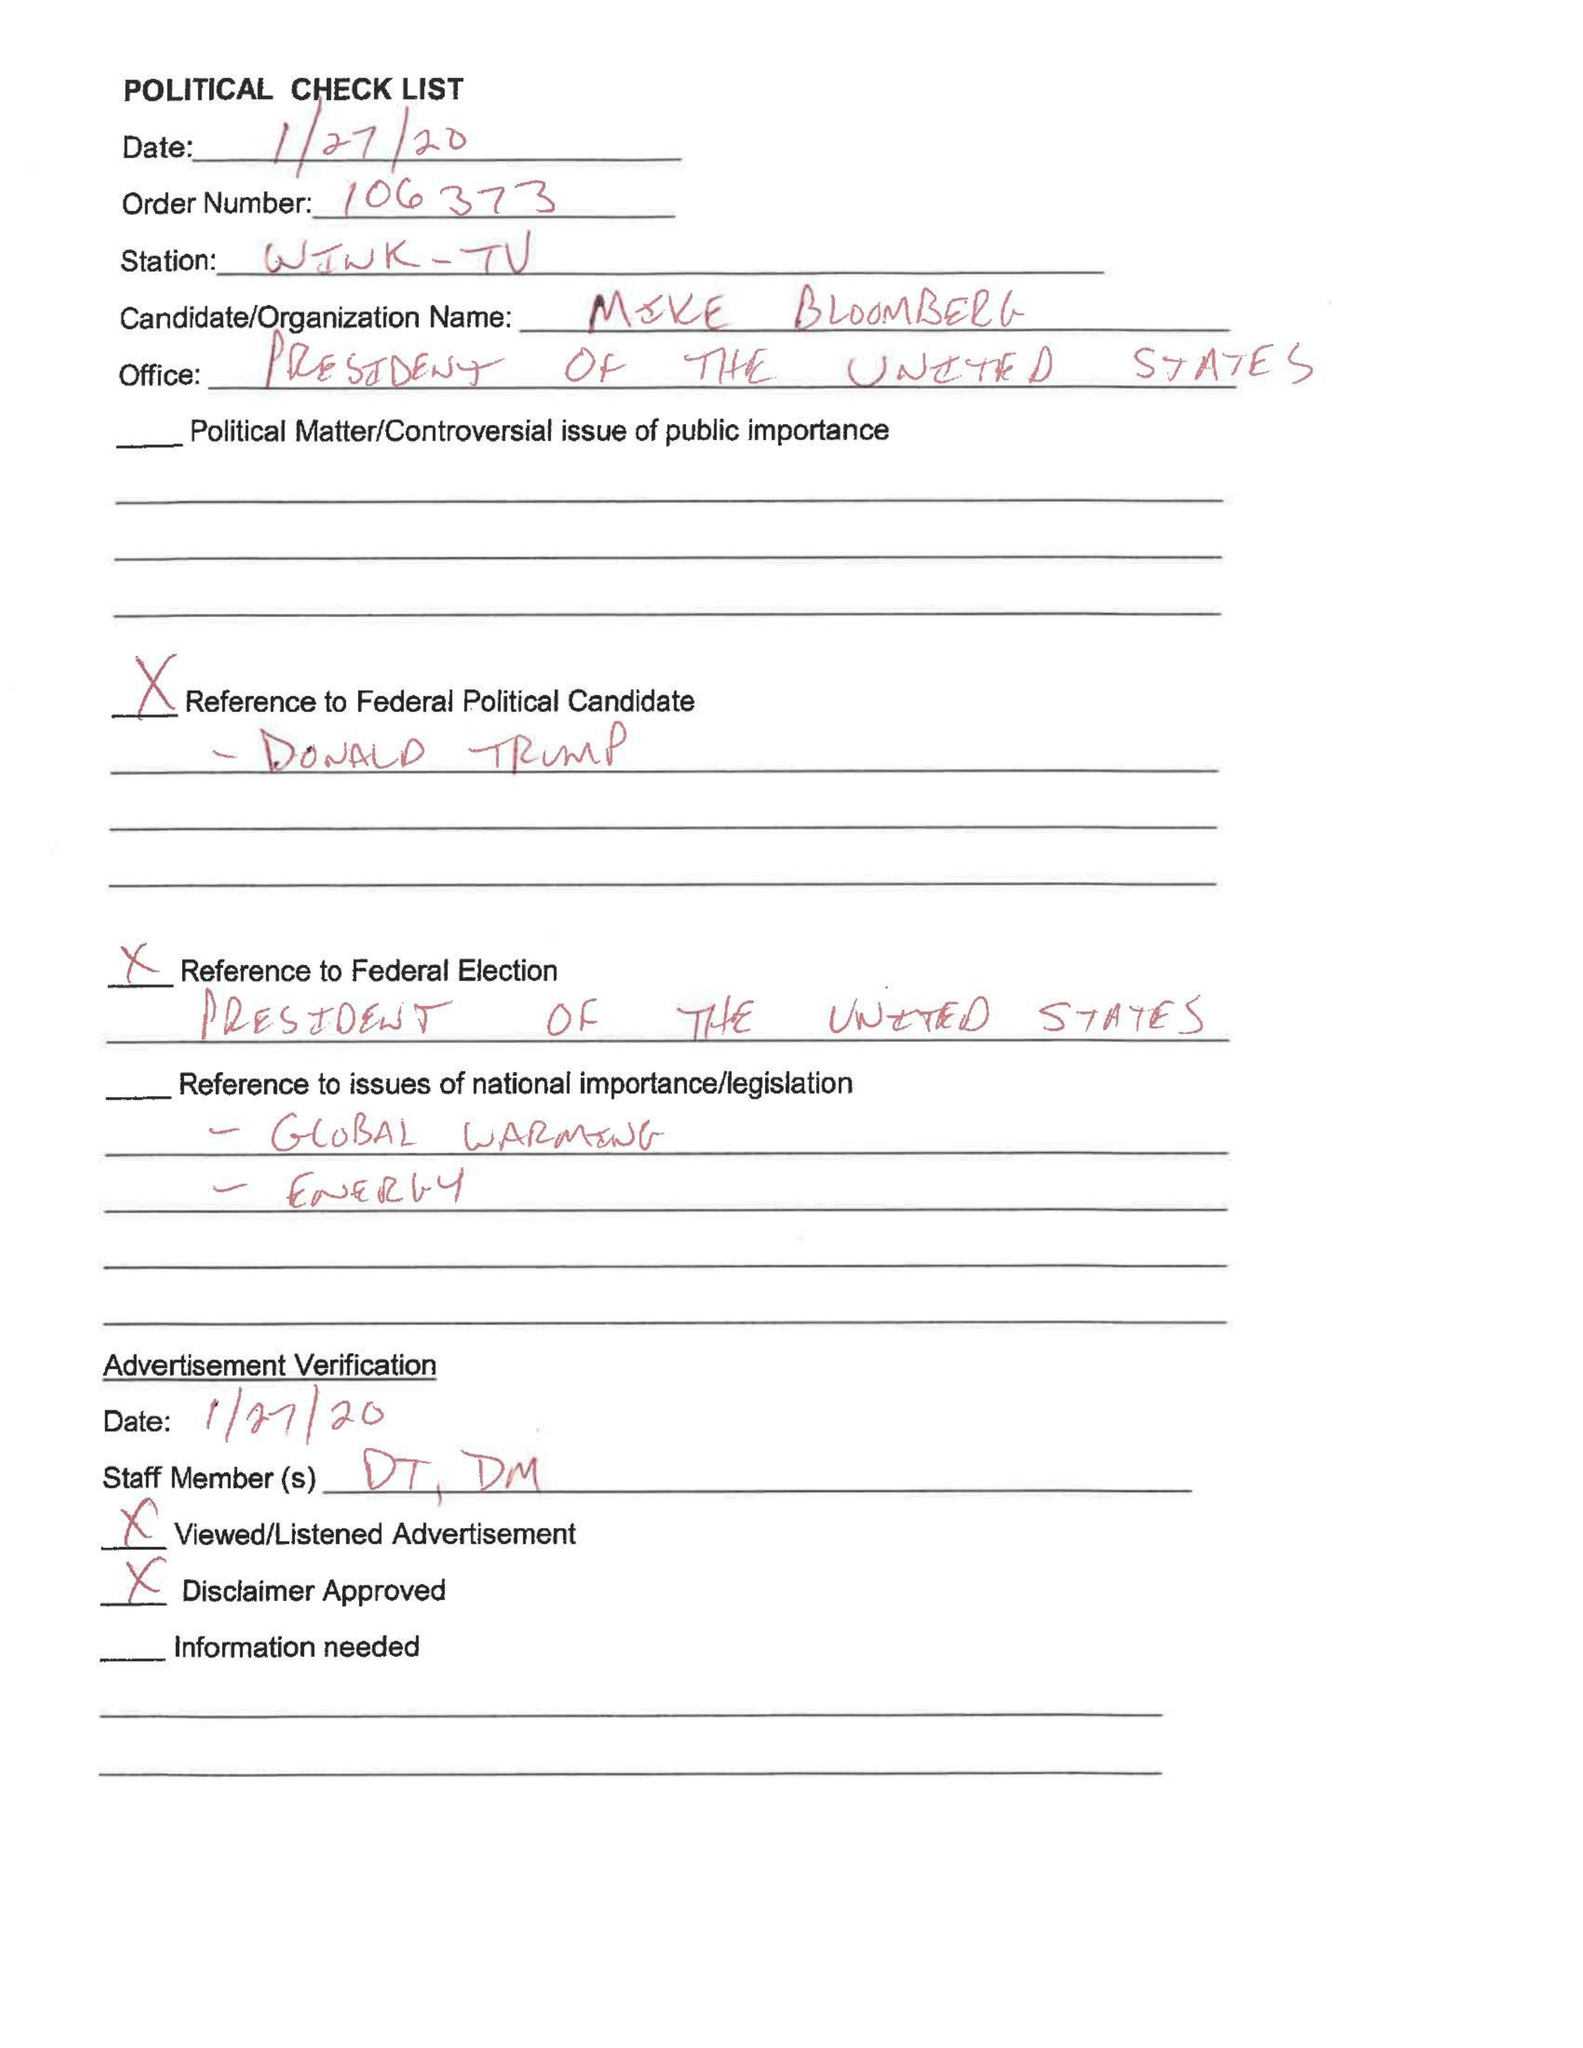What is the value for the contract_num?
Answer the question using a single word or phrase. 106373 